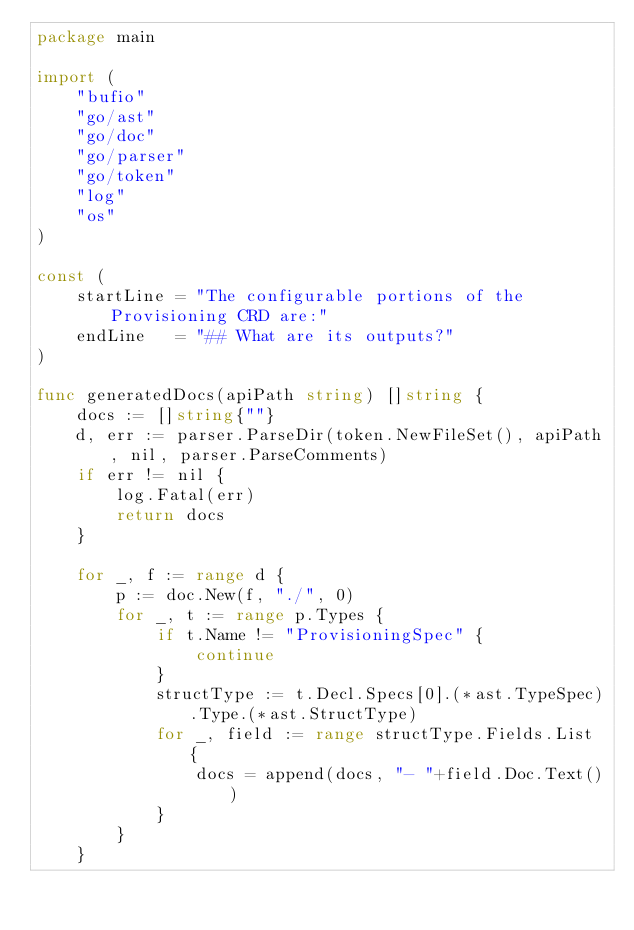Convert code to text. <code><loc_0><loc_0><loc_500><loc_500><_Go_>package main

import (
	"bufio"
	"go/ast"
	"go/doc"
	"go/parser"
	"go/token"
	"log"
	"os"
)

const (
	startLine = "The configurable portions of the Provisioning CRD are:"
	endLine   = "## What are its outputs?"
)

func generatedDocs(apiPath string) []string {
	docs := []string{""}
	d, err := parser.ParseDir(token.NewFileSet(), apiPath, nil, parser.ParseComments)
	if err != nil {
		log.Fatal(err)
		return docs
	}

	for _, f := range d {
		p := doc.New(f, "./", 0)
		for _, t := range p.Types {
			if t.Name != "ProvisioningSpec" {
				continue
			}
			structType := t.Decl.Specs[0].(*ast.TypeSpec).Type.(*ast.StructType)
			for _, field := range structType.Fields.List {
				docs = append(docs, "- "+field.Doc.Text())
			}
		}
	}</code> 